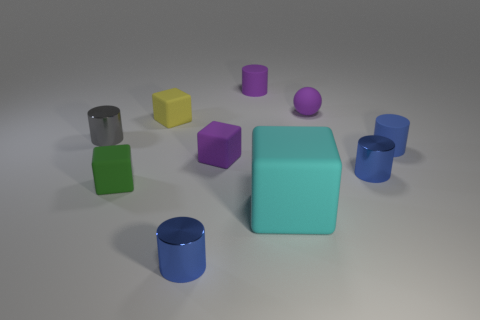The cylinder that is the same color as the small sphere is what size?
Make the answer very short. Small. What number of objects are either matte cylinders that are behind the tiny gray cylinder or tiny cylinders to the right of the large cyan matte object?
Offer a very short reply. 3. What number of other yellow matte things are the same shape as the yellow rubber object?
Your answer should be compact. 0. What is the tiny purple object that is both behind the gray object and in front of the purple cylinder made of?
Your answer should be compact. Rubber. There is a yellow matte block; what number of small purple objects are behind it?
Your response must be concise. 2. What number of purple matte spheres are there?
Your response must be concise. 1. Does the gray metallic cylinder have the same size as the cyan matte block?
Provide a short and direct response. No. There is a purple matte object that is to the right of the tiny matte cylinder behind the gray cylinder; are there any cyan matte objects to the left of it?
Offer a terse response. Yes. There is a small purple object that is the same shape as the yellow matte thing; what is it made of?
Give a very brief answer. Rubber. What is the color of the tiny block that is behind the tiny blue rubber cylinder?
Keep it short and to the point. Yellow. 